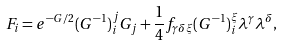<formula> <loc_0><loc_0><loc_500><loc_500>F _ { i } = e ^ { - G / 2 } ( G ^ { - 1 } ) _ { i } ^ { j } G _ { j } + \frac { 1 } { 4 } f _ { \gamma \delta \xi } ( G ^ { - 1 } ) _ { i } ^ { \xi } { \lambda } ^ { \gamma } { \lambda } ^ { \delta } ,</formula> 